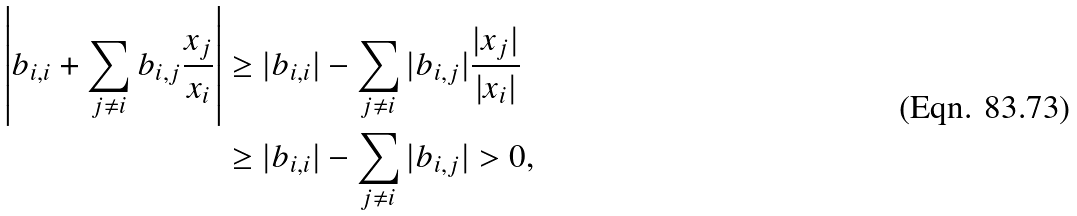<formula> <loc_0><loc_0><loc_500><loc_500>\left | b _ { i , i } + \sum _ { j \not = i } b _ { i , j } \frac { x _ { j } } { x _ { i } } \right | & \geq | b _ { i , i } | - \sum _ { j \not = i } | b _ { i , j } | \frac { | x _ { j } | } { | x _ { i } | } \\ & \geq | b _ { i , i } | - \sum _ { j \not = i } | b _ { i , j } | > 0 ,</formula> 